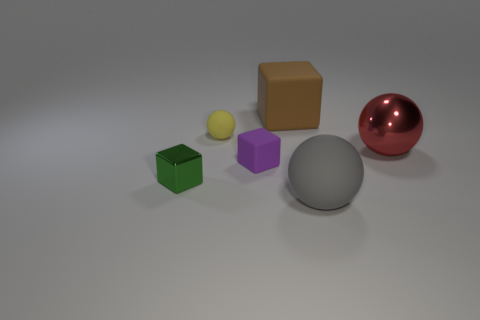Are there any objects in front of the small yellow matte ball?
Your response must be concise. Yes. What number of objects are things that are on the left side of the yellow rubber thing or large objects behind the small yellow matte sphere?
Keep it short and to the point. 2. There is another large thing that is the same shape as the gray thing; what is its color?
Keep it short and to the point. Red. There is a rubber object that is right of the yellow object and behind the red thing; what shape is it?
Make the answer very short. Cube. Is the number of small purple matte blocks greater than the number of tiny things?
Make the answer very short. No. What material is the green block?
Provide a succinct answer. Metal. What is the size of the gray rubber object that is the same shape as the red shiny object?
Provide a succinct answer. Large. Are there any large rubber balls to the right of the big matte object behind the big gray rubber sphere?
Keep it short and to the point. Yes. What number of other things are the same shape as the large gray object?
Your answer should be compact. 2. Are there more matte things that are in front of the green metallic thing than small yellow matte objects that are on the right side of the small purple matte cube?
Give a very brief answer. Yes. 